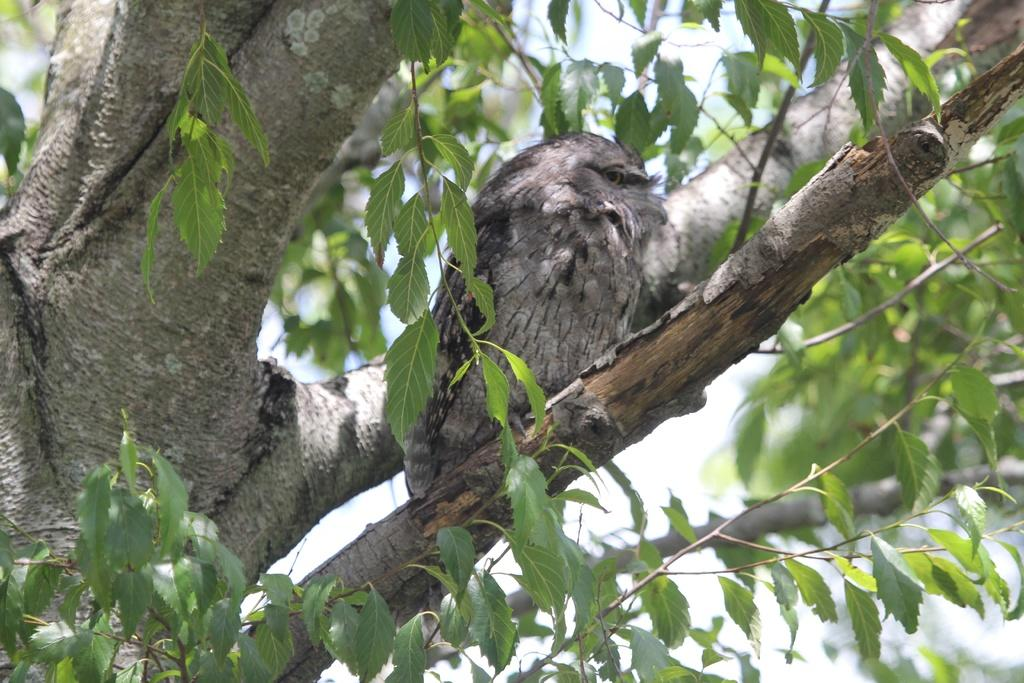What type of animal is in the image? There is a bird in the image. Where is the bird located in the image? The bird is on a branch. What type of vegetation is visible in the image? There are trees in the image. What part of the natural environment is visible in the image? The sky is visible in the background of the image. What type of rings does the bird's grandmother wear in the image? There is no mention of a grandmother or rings in the image; it features a bird on a branch with trees and the sky visible in the background. 